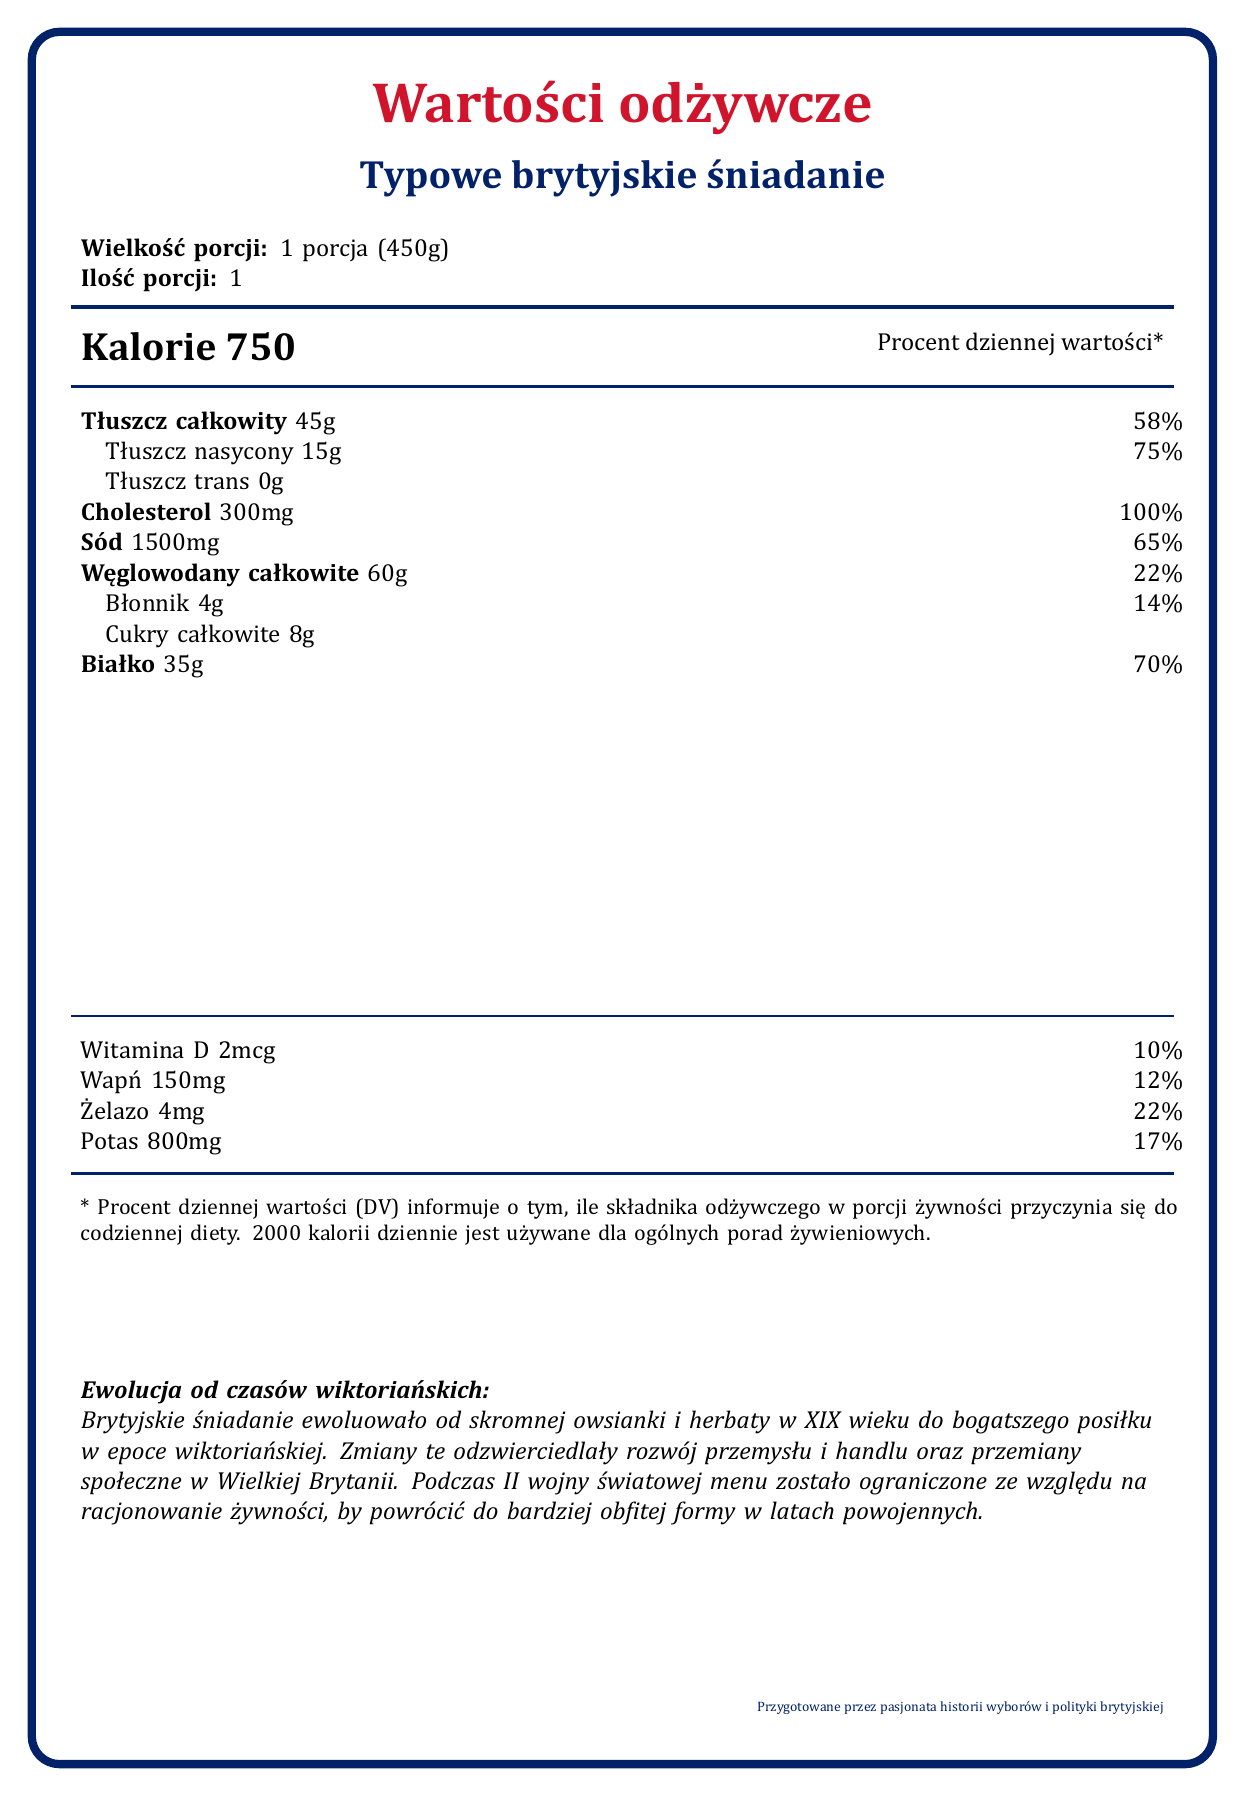What is the serving size of the typical British breakfast? The document specifies that the serving size is 1 porcja (450g).
Answer: 1 porcja (450g) How many calories does one serving of the typical British breakfast contain? The document lists the number of calories per serving as 750.
Answer: 750 What is the total amount of cholesterol in the typical British breakfast? According to the document, the cholesterol content is 300mg.
Answer: 300mg How much dietary fiber is in one serving of the typical British breakfast? The document indicates that there are 4 grams of dietary fiber per serving.
Answer: 4g What are the two largest sources of calories in this meal? Tłuszcz całkowity (45g) and Białko (35g) are the two largest sources of calories.
Answer: Tłuszcz całkowity and Białko What percentage of the daily value for sodium does the typical British breakfast meet? The document states that the sodium content is 1500mg, which is 65% of the daily value.
Answer: 65% True or False: The Full English Breakfast evolved significantly from the Victorian era until now. The document mentions that the typical British breakfast evolved significantly from the Victorian era, reflecting industrial and social changes.
Answer: True Which of the following is NOT an ingredient listed in the typical British breakfast? A. Bekon B. Czarnego pudingu C. Ryż D. Fasolki w sosie pomidorowym The typical British breakfast ingredients listed do not include rice (ryż).
Answer: C. Ryż How did the Second World War impact the typical British breakfast? A. It became more extravagant B. It remained the same C. It became more modest D. New dishes were introduced The document states that the breakfast became more modest during the Second World War due to food rationing.
Answer: C. It became more modest How many slices of bacon are included in the typical British breakfast mentioned? The ingredients list includes 2 plastry bekonu (slices of bacon).
Answer: 2 plastry bekonu Summarize the document in a few sentences. The document is a combination of nutritional facts, historical evolution, and cultural significance related to a typical British breakfast, explaining how it transformed over time and reflecting broader socio-political changes.
Answer: The document provides nutritional information and historical context for a typical British breakfast. It details the serving size, caloric content, and values for various nutrients such as fats, cholesterol, and sodium. The document also discusses the evolution of the breakfast from the Victorian era, its cultural significance, and the impact of socio-political events such as the Second World War on its composition. How does the typical British breakfast reflect the socio-political changes in the UK? The document explains how industrial growth allowed for a more elaborate breakfast, and wartime rationing made it more modest.
Answer: It evolved from a simple meal to a more elaborate one, reflecting industrial growth and social changes, and became modest during WWII due to food rationing. What is the total amount of potassium in one serving of the typical British breakfast? The document specifies that the potassium content is 800mg per serving.
Answer: 800mg Can the exact amount of vitamin C in the typical British breakfast be determined from this document? The document does not provide details about the vitamin C content.
Answer: Not enough information Which meal component makes up the largest percentage of daily value for any nutrient? A. Calcium B. Sodium C. Cholesterol D. Total Fat Cholesterol makes up 100% of the daily value according to the document.
Answer: C. Cholesterol 